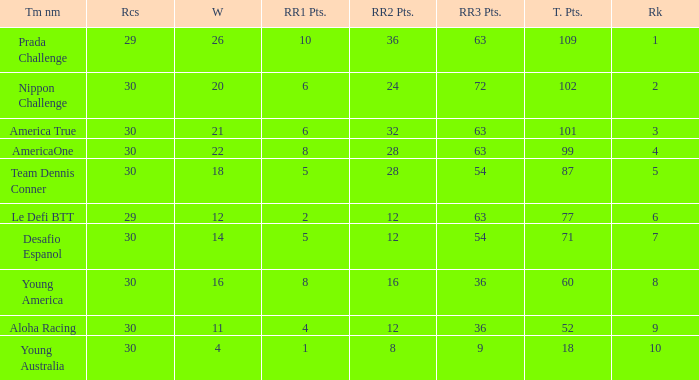Name the total number of rr2 pts for won being 11 1.0. 